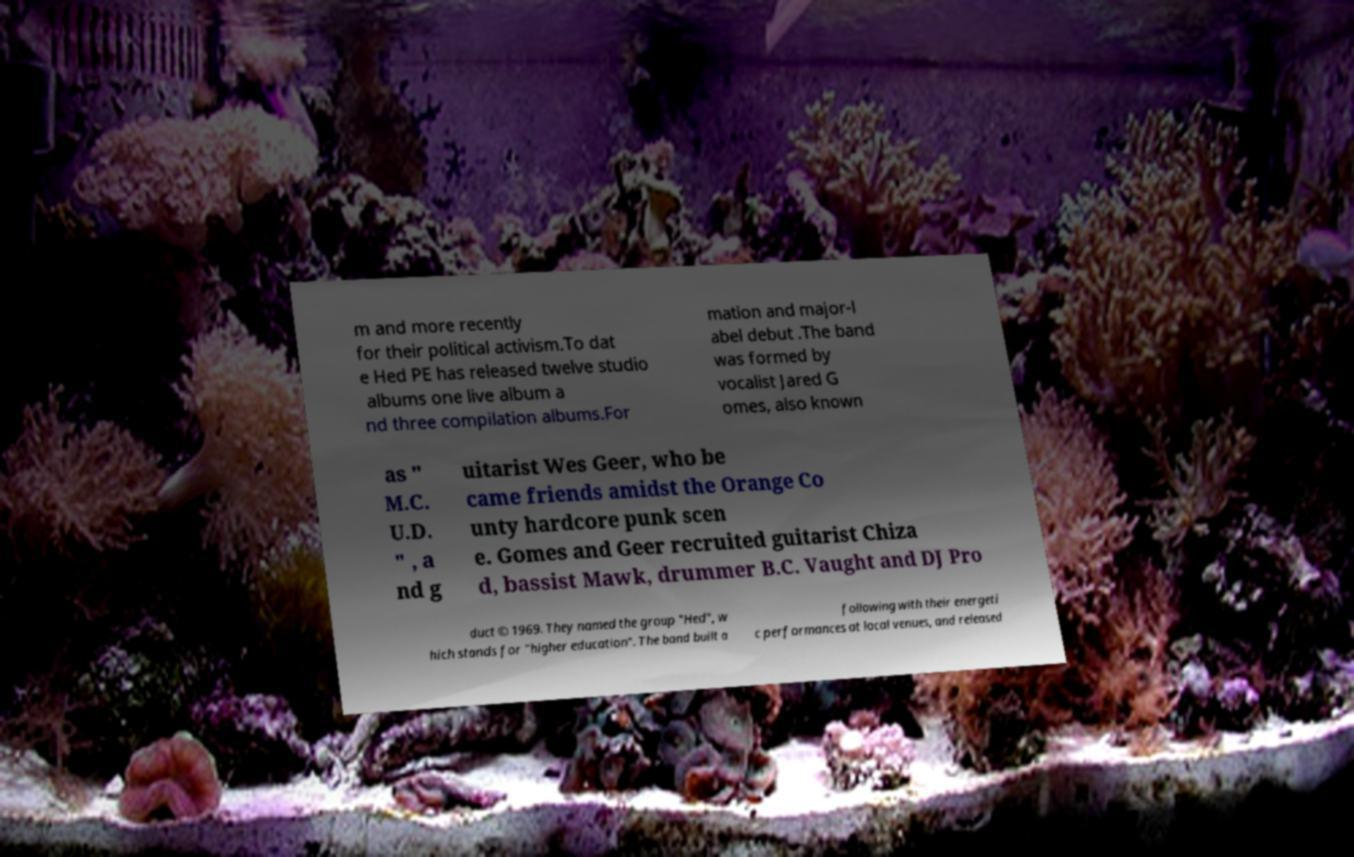Can you accurately transcribe the text from the provided image for me? m and more recently for their political activism.To dat e Hed PE has released twelve studio albums one live album a nd three compilation albums.For mation and major-l abel debut .The band was formed by vocalist Jared G omes, also known as " M.C. U.D. " , a nd g uitarist Wes Geer, who be came friends amidst the Orange Co unty hardcore punk scen e. Gomes and Geer recruited guitarist Chiza d, bassist Mawk, drummer B.C. Vaught and DJ Pro duct © 1969. They named the group "Hed", w hich stands for "higher education". The band built a following with their energeti c performances at local venues, and released 